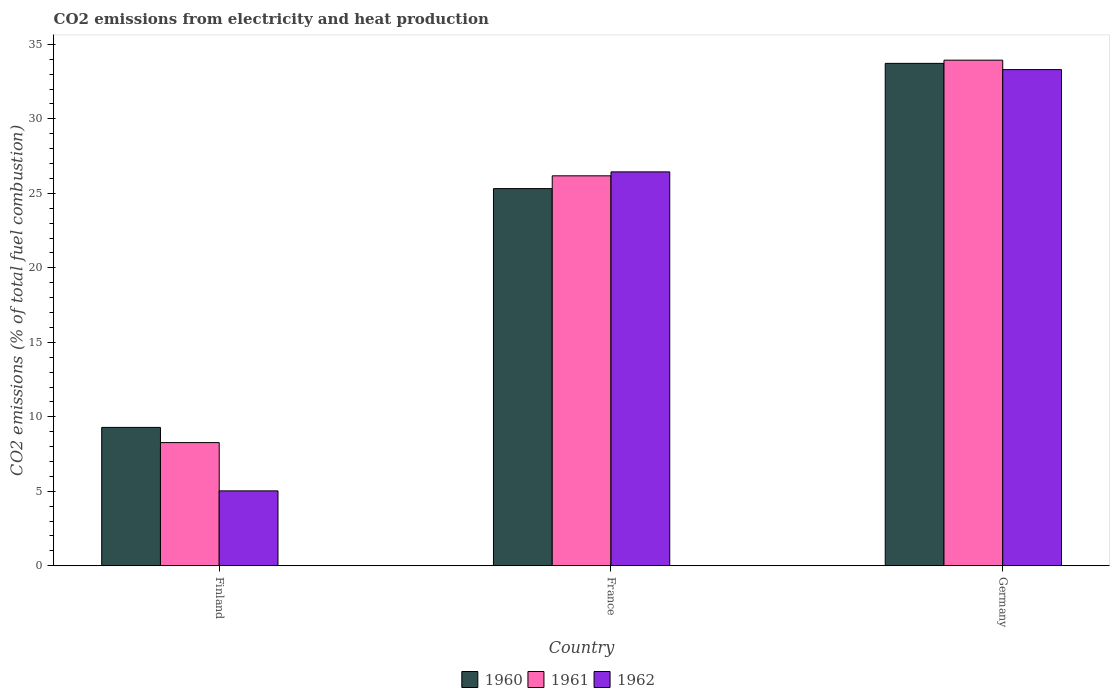How many different coloured bars are there?
Provide a short and direct response. 3. How many groups of bars are there?
Offer a terse response. 3. Are the number of bars per tick equal to the number of legend labels?
Keep it short and to the point. Yes. How many bars are there on the 2nd tick from the left?
Your response must be concise. 3. What is the amount of CO2 emitted in 1960 in France?
Your response must be concise. 25.32. Across all countries, what is the maximum amount of CO2 emitted in 1962?
Ensure brevity in your answer.  33.31. Across all countries, what is the minimum amount of CO2 emitted in 1960?
Provide a short and direct response. 9.29. In which country was the amount of CO2 emitted in 1960 minimum?
Offer a terse response. Finland. What is the total amount of CO2 emitted in 1961 in the graph?
Provide a short and direct response. 68.38. What is the difference between the amount of CO2 emitted in 1960 in France and that in Germany?
Your answer should be compact. -8.41. What is the difference between the amount of CO2 emitted in 1961 in France and the amount of CO2 emitted in 1962 in Germany?
Your answer should be compact. -7.13. What is the average amount of CO2 emitted in 1962 per country?
Provide a short and direct response. 21.59. What is the difference between the amount of CO2 emitted of/in 1960 and amount of CO2 emitted of/in 1961 in Finland?
Make the answer very short. 1.02. What is the ratio of the amount of CO2 emitted in 1960 in Finland to that in Germany?
Your answer should be very brief. 0.28. Is the amount of CO2 emitted in 1962 in France less than that in Germany?
Make the answer very short. Yes. What is the difference between the highest and the second highest amount of CO2 emitted in 1962?
Make the answer very short. 6.87. What is the difference between the highest and the lowest amount of CO2 emitted in 1961?
Ensure brevity in your answer.  25.67. In how many countries, is the amount of CO2 emitted in 1961 greater than the average amount of CO2 emitted in 1961 taken over all countries?
Make the answer very short. 2. What does the 3rd bar from the left in France represents?
Your answer should be compact. 1962. What does the 3rd bar from the right in France represents?
Offer a very short reply. 1960. How many bars are there?
Provide a short and direct response. 9. Are all the bars in the graph horizontal?
Your answer should be very brief. No. What is the difference between two consecutive major ticks on the Y-axis?
Provide a succinct answer. 5. Does the graph contain any zero values?
Ensure brevity in your answer.  No. How many legend labels are there?
Provide a succinct answer. 3. How are the legend labels stacked?
Give a very brief answer. Horizontal. What is the title of the graph?
Ensure brevity in your answer.  CO2 emissions from electricity and heat production. Does "2000" appear as one of the legend labels in the graph?
Offer a terse response. No. What is the label or title of the Y-axis?
Keep it short and to the point. CO2 emissions (% of total fuel combustion). What is the CO2 emissions (% of total fuel combustion) of 1960 in Finland?
Offer a terse response. 9.29. What is the CO2 emissions (% of total fuel combustion) in 1961 in Finland?
Ensure brevity in your answer.  8.27. What is the CO2 emissions (% of total fuel combustion) of 1962 in Finland?
Ensure brevity in your answer.  5.03. What is the CO2 emissions (% of total fuel combustion) of 1960 in France?
Make the answer very short. 25.32. What is the CO2 emissions (% of total fuel combustion) in 1961 in France?
Your answer should be very brief. 26.18. What is the CO2 emissions (% of total fuel combustion) of 1962 in France?
Give a very brief answer. 26.44. What is the CO2 emissions (% of total fuel combustion) in 1960 in Germany?
Give a very brief answer. 33.72. What is the CO2 emissions (% of total fuel combustion) of 1961 in Germany?
Make the answer very short. 33.94. What is the CO2 emissions (% of total fuel combustion) of 1962 in Germany?
Provide a short and direct response. 33.31. Across all countries, what is the maximum CO2 emissions (% of total fuel combustion) in 1960?
Your answer should be compact. 33.72. Across all countries, what is the maximum CO2 emissions (% of total fuel combustion) in 1961?
Offer a very short reply. 33.94. Across all countries, what is the maximum CO2 emissions (% of total fuel combustion) in 1962?
Offer a very short reply. 33.31. Across all countries, what is the minimum CO2 emissions (% of total fuel combustion) of 1960?
Provide a short and direct response. 9.29. Across all countries, what is the minimum CO2 emissions (% of total fuel combustion) of 1961?
Provide a succinct answer. 8.27. Across all countries, what is the minimum CO2 emissions (% of total fuel combustion) in 1962?
Give a very brief answer. 5.03. What is the total CO2 emissions (% of total fuel combustion) in 1960 in the graph?
Keep it short and to the point. 68.33. What is the total CO2 emissions (% of total fuel combustion) of 1961 in the graph?
Your answer should be compact. 68.38. What is the total CO2 emissions (% of total fuel combustion) in 1962 in the graph?
Offer a very short reply. 64.77. What is the difference between the CO2 emissions (% of total fuel combustion) in 1960 in Finland and that in France?
Offer a very short reply. -16.03. What is the difference between the CO2 emissions (% of total fuel combustion) of 1961 in Finland and that in France?
Give a very brief answer. -17.91. What is the difference between the CO2 emissions (% of total fuel combustion) in 1962 in Finland and that in France?
Provide a succinct answer. -21.41. What is the difference between the CO2 emissions (% of total fuel combustion) of 1960 in Finland and that in Germany?
Ensure brevity in your answer.  -24.44. What is the difference between the CO2 emissions (% of total fuel combustion) in 1961 in Finland and that in Germany?
Ensure brevity in your answer.  -25.67. What is the difference between the CO2 emissions (% of total fuel combustion) of 1962 in Finland and that in Germany?
Provide a short and direct response. -28.28. What is the difference between the CO2 emissions (% of total fuel combustion) in 1960 in France and that in Germany?
Offer a terse response. -8.41. What is the difference between the CO2 emissions (% of total fuel combustion) in 1961 in France and that in Germany?
Offer a terse response. -7.76. What is the difference between the CO2 emissions (% of total fuel combustion) in 1962 in France and that in Germany?
Your response must be concise. -6.87. What is the difference between the CO2 emissions (% of total fuel combustion) in 1960 in Finland and the CO2 emissions (% of total fuel combustion) in 1961 in France?
Ensure brevity in your answer.  -16.89. What is the difference between the CO2 emissions (% of total fuel combustion) in 1960 in Finland and the CO2 emissions (% of total fuel combustion) in 1962 in France?
Give a very brief answer. -17.15. What is the difference between the CO2 emissions (% of total fuel combustion) in 1961 in Finland and the CO2 emissions (% of total fuel combustion) in 1962 in France?
Your answer should be very brief. -18.17. What is the difference between the CO2 emissions (% of total fuel combustion) in 1960 in Finland and the CO2 emissions (% of total fuel combustion) in 1961 in Germany?
Your answer should be very brief. -24.65. What is the difference between the CO2 emissions (% of total fuel combustion) in 1960 in Finland and the CO2 emissions (% of total fuel combustion) in 1962 in Germany?
Offer a terse response. -24.02. What is the difference between the CO2 emissions (% of total fuel combustion) in 1961 in Finland and the CO2 emissions (% of total fuel combustion) in 1962 in Germany?
Make the answer very short. -25.04. What is the difference between the CO2 emissions (% of total fuel combustion) of 1960 in France and the CO2 emissions (% of total fuel combustion) of 1961 in Germany?
Ensure brevity in your answer.  -8.62. What is the difference between the CO2 emissions (% of total fuel combustion) in 1960 in France and the CO2 emissions (% of total fuel combustion) in 1962 in Germany?
Your response must be concise. -7.99. What is the difference between the CO2 emissions (% of total fuel combustion) in 1961 in France and the CO2 emissions (% of total fuel combustion) in 1962 in Germany?
Your response must be concise. -7.13. What is the average CO2 emissions (% of total fuel combustion) in 1960 per country?
Offer a terse response. 22.78. What is the average CO2 emissions (% of total fuel combustion) of 1961 per country?
Keep it short and to the point. 22.79. What is the average CO2 emissions (% of total fuel combustion) of 1962 per country?
Offer a terse response. 21.59. What is the difference between the CO2 emissions (% of total fuel combustion) in 1960 and CO2 emissions (% of total fuel combustion) in 1961 in Finland?
Offer a very short reply. 1.02. What is the difference between the CO2 emissions (% of total fuel combustion) in 1960 and CO2 emissions (% of total fuel combustion) in 1962 in Finland?
Offer a very short reply. 4.26. What is the difference between the CO2 emissions (% of total fuel combustion) in 1961 and CO2 emissions (% of total fuel combustion) in 1962 in Finland?
Give a very brief answer. 3.24. What is the difference between the CO2 emissions (% of total fuel combustion) in 1960 and CO2 emissions (% of total fuel combustion) in 1961 in France?
Provide a short and direct response. -0.86. What is the difference between the CO2 emissions (% of total fuel combustion) in 1960 and CO2 emissions (% of total fuel combustion) in 1962 in France?
Offer a terse response. -1.12. What is the difference between the CO2 emissions (% of total fuel combustion) in 1961 and CO2 emissions (% of total fuel combustion) in 1962 in France?
Your response must be concise. -0.26. What is the difference between the CO2 emissions (% of total fuel combustion) in 1960 and CO2 emissions (% of total fuel combustion) in 1961 in Germany?
Offer a terse response. -0.21. What is the difference between the CO2 emissions (% of total fuel combustion) of 1960 and CO2 emissions (% of total fuel combustion) of 1962 in Germany?
Provide a short and direct response. 0.42. What is the difference between the CO2 emissions (% of total fuel combustion) in 1961 and CO2 emissions (% of total fuel combustion) in 1962 in Germany?
Offer a very short reply. 0.63. What is the ratio of the CO2 emissions (% of total fuel combustion) of 1960 in Finland to that in France?
Your response must be concise. 0.37. What is the ratio of the CO2 emissions (% of total fuel combustion) of 1961 in Finland to that in France?
Ensure brevity in your answer.  0.32. What is the ratio of the CO2 emissions (% of total fuel combustion) of 1962 in Finland to that in France?
Your answer should be compact. 0.19. What is the ratio of the CO2 emissions (% of total fuel combustion) of 1960 in Finland to that in Germany?
Ensure brevity in your answer.  0.28. What is the ratio of the CO2 emissions (% of total fuel combustion) in 1961 in Finland to that in Germany?
Offer a terse response. 0.24. What is the ratio of the CO2 emissions (% of total fuel combustion) in 1962 in Finland to that in Germany?
Offer a terse response. 0.15. What is the ratio of the CO2 emissions (% of total fuel combustion) of 1960 in France to that in Germany?
Provide a succinct answer. 0.75. What is the ratio of the CO2 emissions (% of total fuel combustion) in 1961 in France to that in Germany?
Offer a very short reply. 0.77. What is the ratio of the CO2 emissions (% of total fuel combustion) of 1962 in France to that in Germany?
Provide a short and direct response. 0.79. What is the difference between the highest and the second highest CO2 emissions (% of total fuel combustion) in 1960?
Keep it short and to the point. 8.41. What is the difference between the highest and the second highest CO2 emissions (% of total fuel combustion) in 1961?
Your response must be concise. 7.76. What is the difference between the highest and the second highest CO2 emissions (% of total fuel combustion) in 1962?
Your answer should be very brief. 6.87. What is the difference between the highest and the lowest CO2 emissions (% of total fuel combustion) of 1960?
Your response must be concise. 24.44. What is the difference between the highest and the lowest CO2 emissions (% of total fuel combustion) in 1961?
Provide a short and direct response. 25.67. What is the difference between the highest and the lowest CO2 emissions (% of total fuel combustion) of 1962?
Your answer should be very brief. 28.28. 